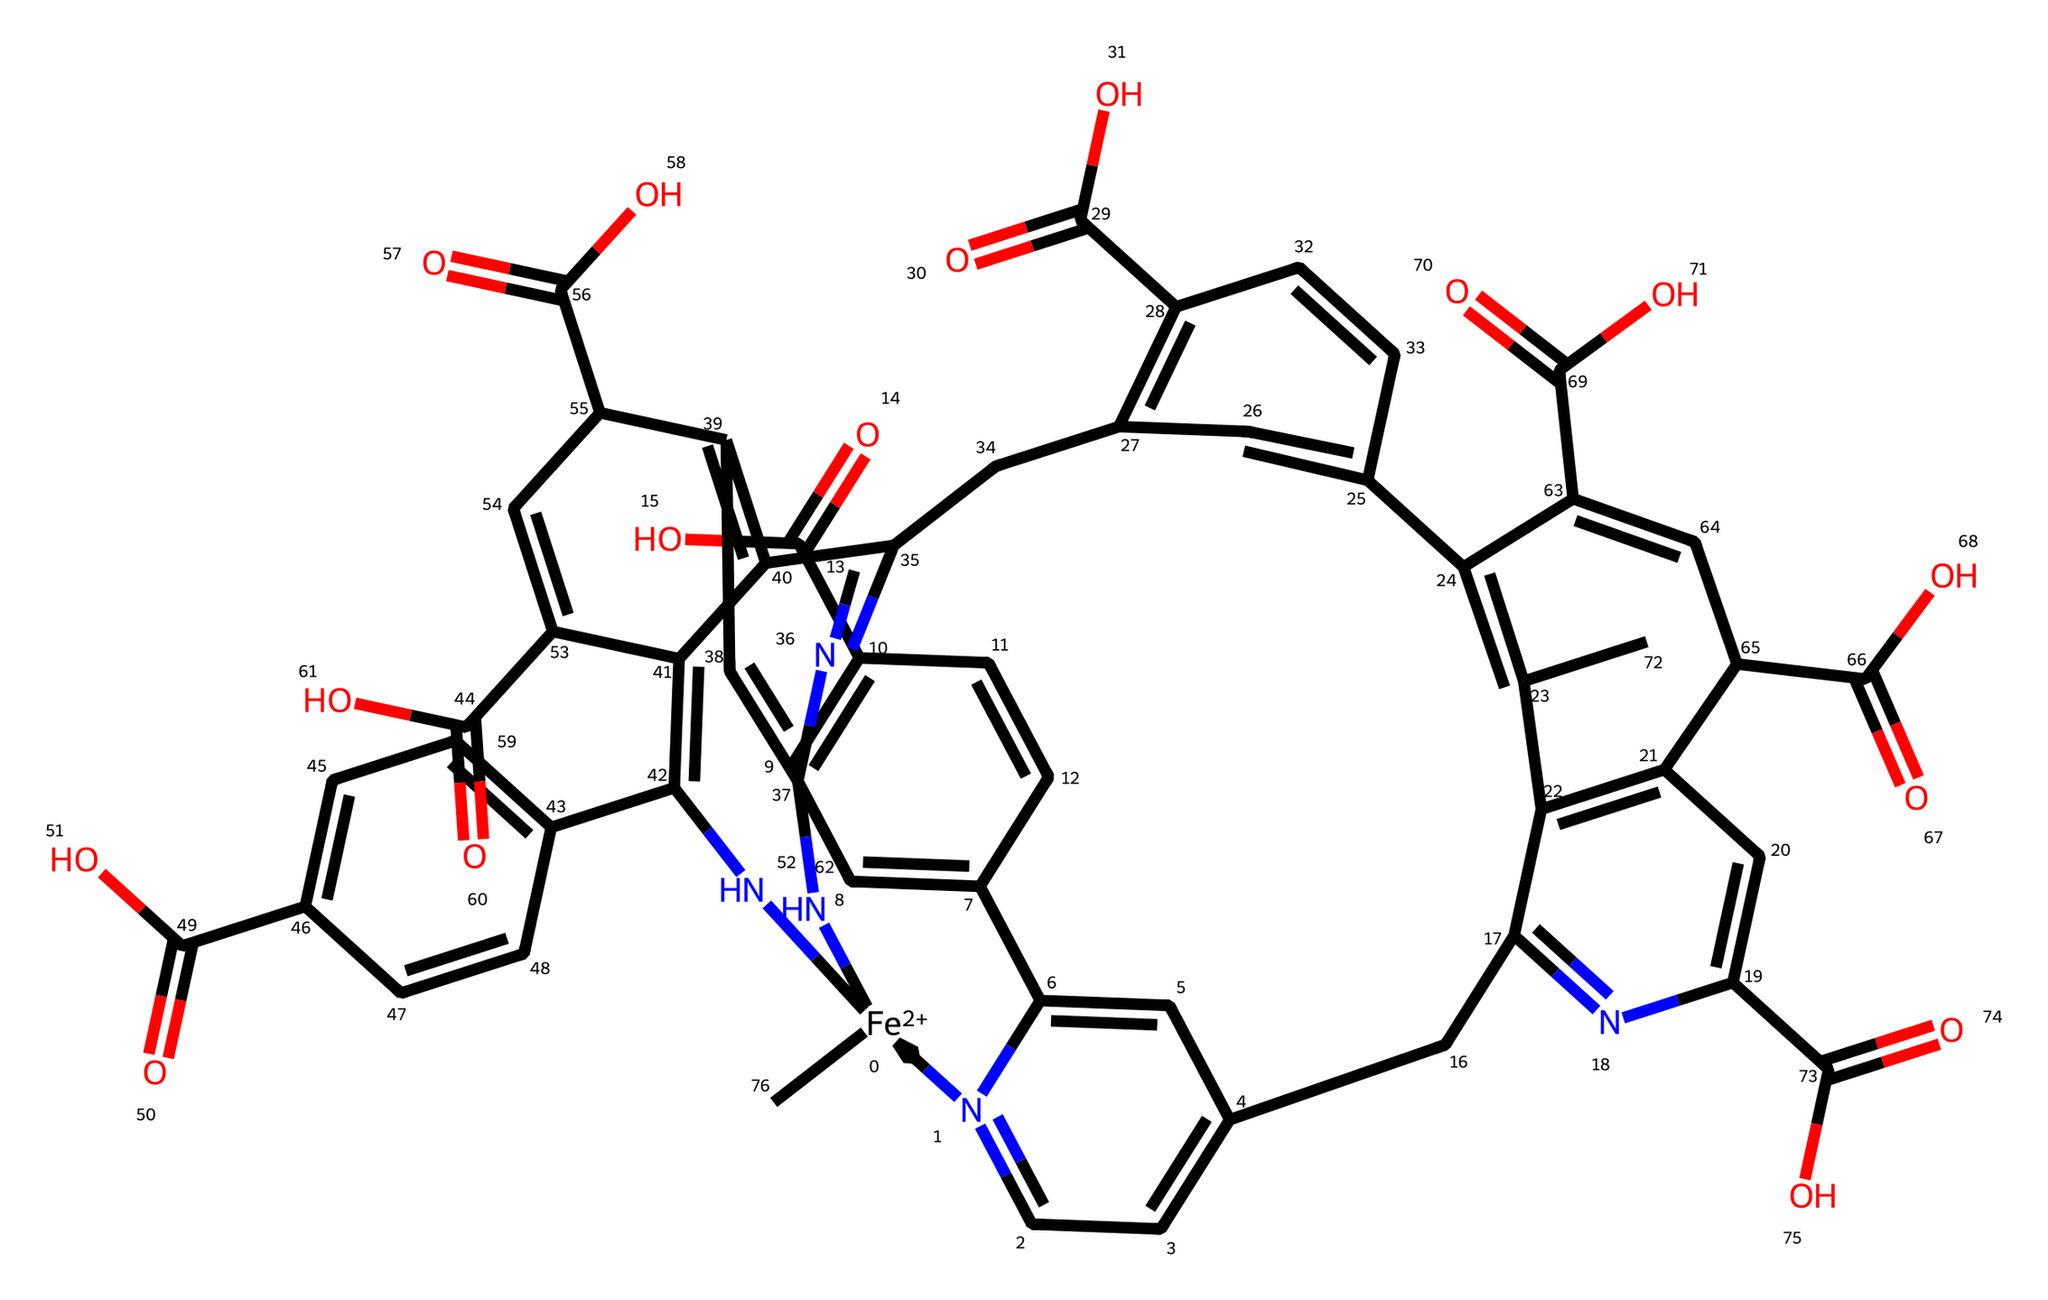What is the oxidation state of iron in hemoglobin? The SMILES representation includes [Fe+2], indicating that the iron atom has a +2 oxidation state.
Answer: +2 How many carbon atoms are present in the structure of hemoglobin? By analyzing the SMILES, there are multiple carbon-containing structures indicating a total of 40 carbon atoms in the entire structure.
Answer: 40 What type of coordination compound is hemoglobin classified as? Hemoglobin is classified as a metalloprotein since it contains a metal ion (iron) coordinated with organic molecules (hemes).
Answer: metalloprotein How many nitrogen atoms are in the hemoglobin structure? By counting the nitrogen elements represented in the SMILES, there are 8 nitrogen atoms in total.
Answer: 8 What role does the iron in hemoglobin play in the blood? The iron in hemoglobin coordinates with oxygen molecules, enabling the transport of oxygen from the lungs to tissues.
Answer: transport of oxygen What is the significance of the porphyrin-like structure observed in hemoglobin? The porphyrin structure allows for the coordination of the iron atom and is crucial for the binding and release of oxygen in the body.
Answer: coordination of iron How many oxygen molecules can one hemoglobin molecule bind? One hemoglobin molecule can bind up to four oxygen molecules, one for each iron atom in its heme groups.
Answer: four 